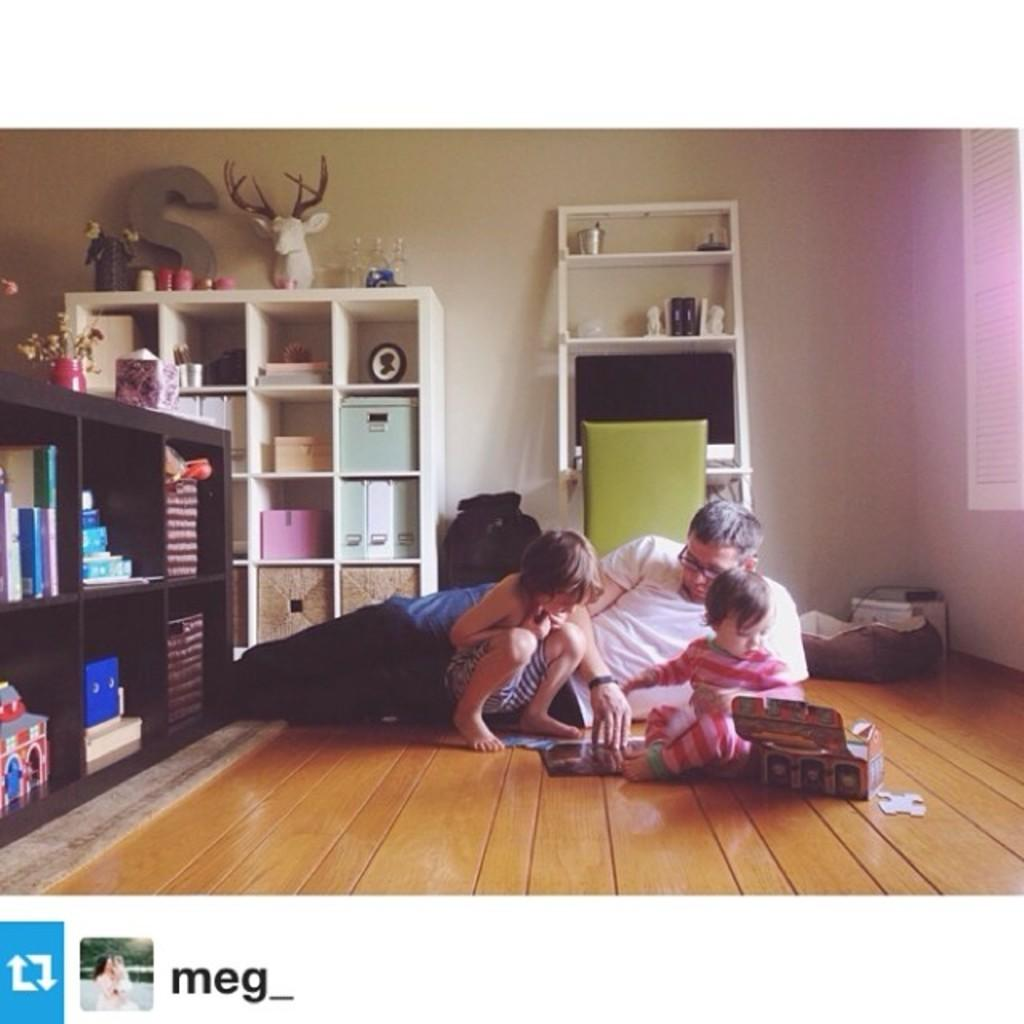<image>
Give a short and clear explanation of the subsequent image. a man laying on the floor playing with two little kids with an S displayed behind them on a shelf 